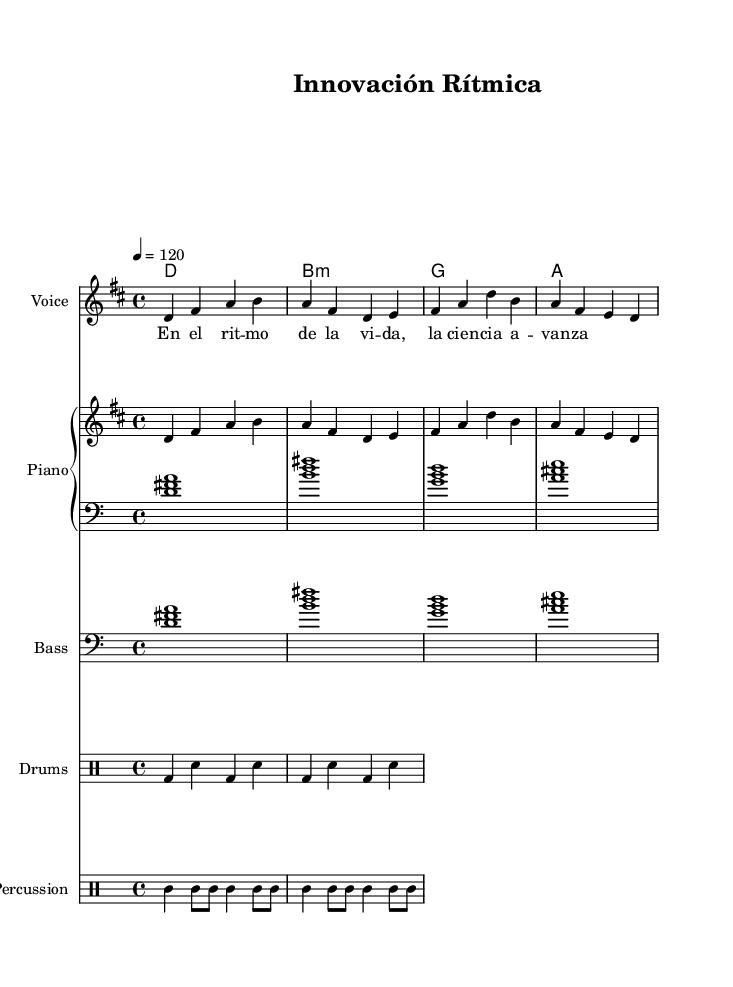What is the key signature of this music? The key signature is indicated by the 'global' block, which shows the key of D major, having two sharps (F# and C#).
Answer: D major What is the time signature of the piece? The time signature is also found in the 'global' block, where it is specified as 4/4, indicating four beats per measure.
Answer: 4/4 What is the tempo marking for this piece? The tempo marking is written in the 'global' block as "4 = 120", which means there are 120 beats per minute.
Answer: 120 How many measures are there in the melody? To determine the number of measures, we can count the groups of beats in the provided melody. Each measure has four beats, and there are eight groups of four, yielding a total of eight measures.
Answer: 8 What type of instruments are included in the score? The score includes a Voice, Piano, Bass, Drums, and Percussion. We can identify them in the 'score' section where different instruments are defined.
Answer: Voice, Piano, Bass, Drums, Percussion What lyrical theme is represented in the lyrics? The lyrics "En el ritmo de la vida, la ciencia avanza" suggest a theme of progress and innovation, reflecting a connection between rhythm and the advancement of science.
Answer: Technological progress What rhythmic style is this piece primarily based on? The piece incorporates Latin American rhythms, evident from the upbeat feel and the incorporation of elements like drums, which are characteristic of this musical genre.
Answer: Latin American rhythms 